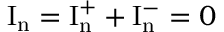<formula> <loc_0><loc_0><loc_500><loc_500>I _ { n } = I _ { n } ^ { + } + I _ { n } ^ { - } = 0</formula> 